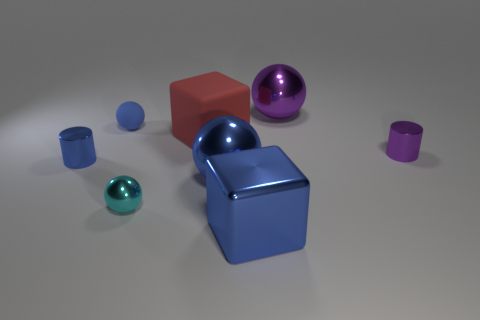Add 2 tiny yellow cylinders. How many objects exist? 10 Subtract all cubes. How many objects are left? 6 Subtract all large balls. Subtract all metal cylinders. How many objects are left? 4 Add 5 cylinders. How many cylinders are left? 7 Add 8 tiny metal cylinders. How many tiny metal cylinders exist? 10 Subtract 0 brown balls. How many objects are left? 8 